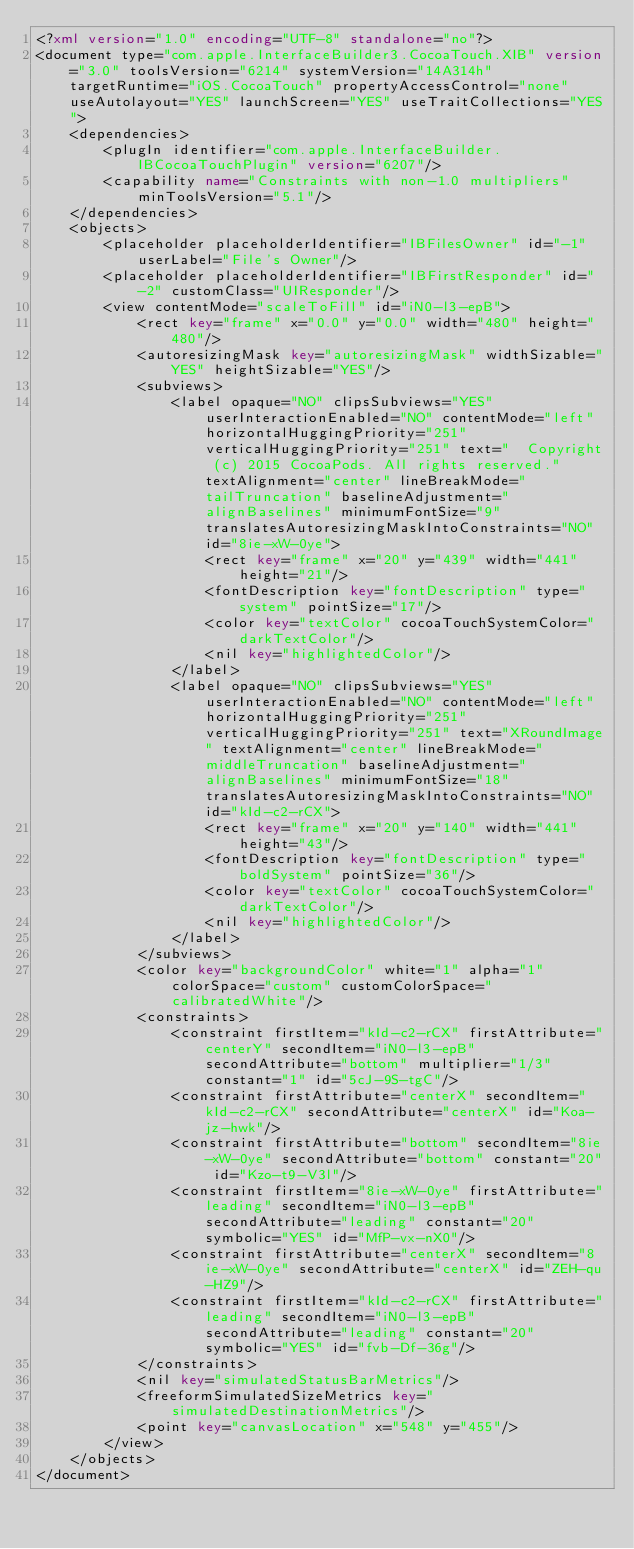Convert code to text. <code><loc_0><loc_0><loc_500><loc_500><_XML_><?xml version="1.0" encoding="UTF-8" standalone="no"?>
<document type="com.apple.InterfaceBuilder3.CocoaTouch.XIB" version="3.0" toolsVersion="6214" systemVersion="14A314h" targetRuntime="iOS.CocoaTouch" propertyAccessControl="none" useAutolayout="YES" launchScreen="YES" useTraitCollections="YES">
    <dependencies>
        <plugIn identifier="com.apple.InterfaceBuilder.IBCocoaTouchPlugin" version="6207"/>
        <capability name="Constraints with non-1.0 multipliers" minToolsVersion="5.1"/>
    </dependencies>
    <objects>
        <placeholder placeholderIdentifier="IBFilesOwner" id="-1" userLabel="File's Owner"/>
        <placeholder placeholderIdentifier="IBFirstResponder" id="-2" customClass="UIResponder"/>
        <view contentMode="scaleToFill" id="iN0-l3-epB">
            <rect key="frame" x="0.0" y="0.0" width="480" height="480"/>
            <autoresizingMask key="autoresizingMask" widthSizable="YES" heightSizable="YES"/>
            <subviews>
                <label opaque="NO" clipsSubviews="YES" userInteractionEnabled="NO" contentMode="left" horizontalHuggingPriority="251" verticalHuggingPriority="251" text="  Copyright (c) 2015 CocoaPods. All rights reserved." textAlignment="center" lineBreakMode="tailTruncation" baselineAdjustment="alignBaselines" minimumFontSize="9" translatesAutoresizingMaskIntoConstraints="NO" id="8ie-xW-0ye">
                    <rect key="frame" x="20" y="439" width="441" height="21"/>
                    <fontDescription key="fontDescription" type="system" pointSize="17"/>
                    <color key="textColor" cocoaTouchSystemColor="darkTextColor"/>
                    <nil key="highlightedColor"/>
                </label>
                <label opaque="NO" clipsSubviews="YES" userInteractionEnabled="NO" contentMode="left" horizontalHuggingPriority="251" verticalHuggingPriority="251" text="XRoundImage" textAlignment="center" lineBreakMode="middleTruncation" baselineAdjustment="alignBaselines" minimumFontSize="18" translatesAutoresizingMaskIntoConstraints="NO" id="kId-c2-rCX">
                    <rect key="frame" x="20" y="140" width="441" height="43"/>
                    <fontDescription key="fontDescription" type="boldSystem" pointSize="36"/>
                    <color key="textColor" cocoaTouchSystemColor="darkTextColor"/>
                    <nil key="highlightedColor"/>
                </label>
            </subviews>
            <color key="backgroundColor" white="1" alpha="1" colorSpace="custom" customColorSpace="calibratedWhite"/>
            <constraints>
                <constraint firstItem="kId-c2-rCX" firstAttribute="centerY" secondItem="iN0-l3-epB" secondAttribute="bottom" multiplier="1/3" constant="1" id="5cJ-9S-tgC"/>
                <constraint firstAttribute="centerX" secondItem="kId-c2-rCX" secondAttribute="centerX" id="Koa-jz-hwk"/>
                <constraint firstAttribute="bottom" secondItem="8ie-xW-0ye" secondAttribute="bottom" constant="20" id="Kzo-t9-V3l"/>
                <constraint firstItem="8ie-xW-0ye" firstAttribute="leading" secondItem="iN0-l3-epB" secondAttribute="leading" constant="20" symbolic="YES" id="MfP-vx-nX0"/>
                <constraint firstAttribute="centerX" secondItem="8ie-xW-0ye" secondAttribute="centerX" id="ZEH-qu-HZ9"/>
                <constraint firstItem="kId-c2-rCX" firstAttribute="leading" secondItem="iN0-l3-epB" secondAttribute="leading" constant="20" symbolic="YES" id="fvb-Df-36g"/>
            </constraints>
            <nil key="simulatedStatusBarMetrics"/>
            <freeformSimulatedSizeMetrics key="simulatedDestinationMetrics"/>
            <point key="canvasLocation" x="548" y="455"/>
        </view>
    </objects>
</document>
</code> 